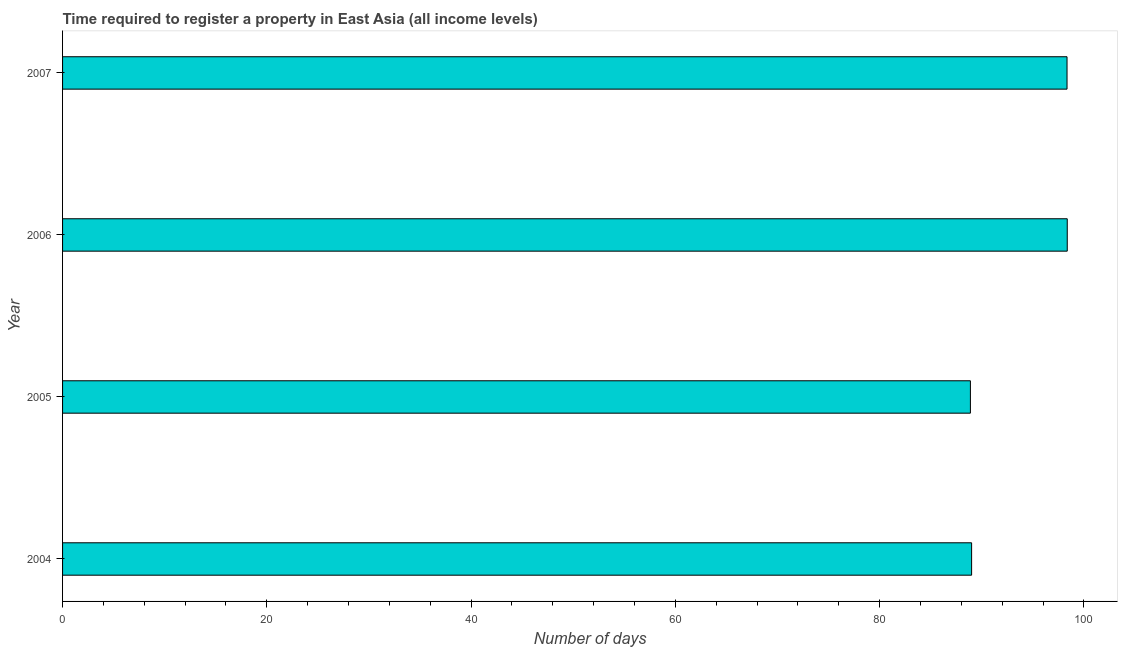Does the graph contain grids?
Provide a succinct answer. No. What is the title of the graph?
Provide a short and direct response. Time required to register a property in East Asia (all income levels). What is the label or title of the X-axis?
Offer a terse response. Number of days. What is the number of days required to register property in 2005?
Your answer should be compact. 88.88. Across all years, what is the maximum number of days required to register property?
Make the answer very short. 98.36. Across all years, what is the minimum number of days required to register property?
Your answer should be compact. 88.88. What is the sum of the number of days required to register property?
Give a very brief answer. 374.59. What is the difference between the number of days required to register property in 2005 and 2007?
Ensure brevity in your answer.  -9.46. What is the average number of days required to register property per year?
Keep it short and to the point. 93.65. What is the median number of days required to register property?
Offer a terse response. 93.67. Do a majority of the years between 2007 and 2005 (inclusive) have number of days required to register property greater than 16 days?
Ensure brevity in your answer.  Yes. What is the ratio of the number of days required to register property in 2005 to that in 2006?
Your response must be concise. 0.9. Is the number of days required to register property in 2005 less than that in 2006?
Offer a terse response. Yes. What is the difference between the highest and the second highest number of days required to register property?
Offer a very short reply. 0.02. What is the difference between the highest and the lowest number of days required to register property?
Offer a terse response. 9.48. How many bars are there?
Your response must be concise. 4. Are all the bars in the graph horizontal?
Keep it short and to the point. Yes. How many years are there in the graph?
Make the answer very short. 4. What is the difference between two consecutive major ticks on the X-axis?
Provide a succinct answer. 20. Are the values on the major ticks of X-axis written in scientific E-notation?
Your answer should be very brief. No. What is the Number of days of 2004?
Offer a terse response. 89. What is the Number of days in 2005?
Make the answer very short. 88.88. What is the Number of days in 2006?
Ensure brevity in your answer.  98.36. What is the Number of days in 2007?
Ensure brevity in your answer.  98.34. What is the difference between the Number of days in 2004 and 2005?
Ensure brevity in your answer.  0.12. What is the difference between the Number of days in 2004 and 2006?
Your response must be concise. -9.36. What is the difference between the Number of days in 2004 and 2007?
Offer a very short reply. -9.34. What is the difference between the Number of days in 2005 and 2006?
Keep it short and to the point. -9.48. What is the difference between the Number of days in 2005 and 2007?
Your answer should be compact. -9.46. What is the difference between the Number of days in 2006 and 2007?
Make the answer very short. 0.02. What is the ratio of the Number of days in 2004 to that in 2005?
Make the answer very short. 1. What is the ratio of the Number of days in 2004 to that in 2006?
Ensure brevity in your answer.  0.91. What is the ratio of the Number of days in 2004 to that in 2007?
Provide a succinct answer. 0.91. What is the ratio of the Number of days in 2005 to that in 2006?
Provide a succinct answer. 0.9. What is the ratio of the Number of days in 2005 to that in 2007?
Provide a succinct answer. 0.9. What is the ratio of the Number of days in 2006 to that in 2007?
Your response must be concise. 1. 